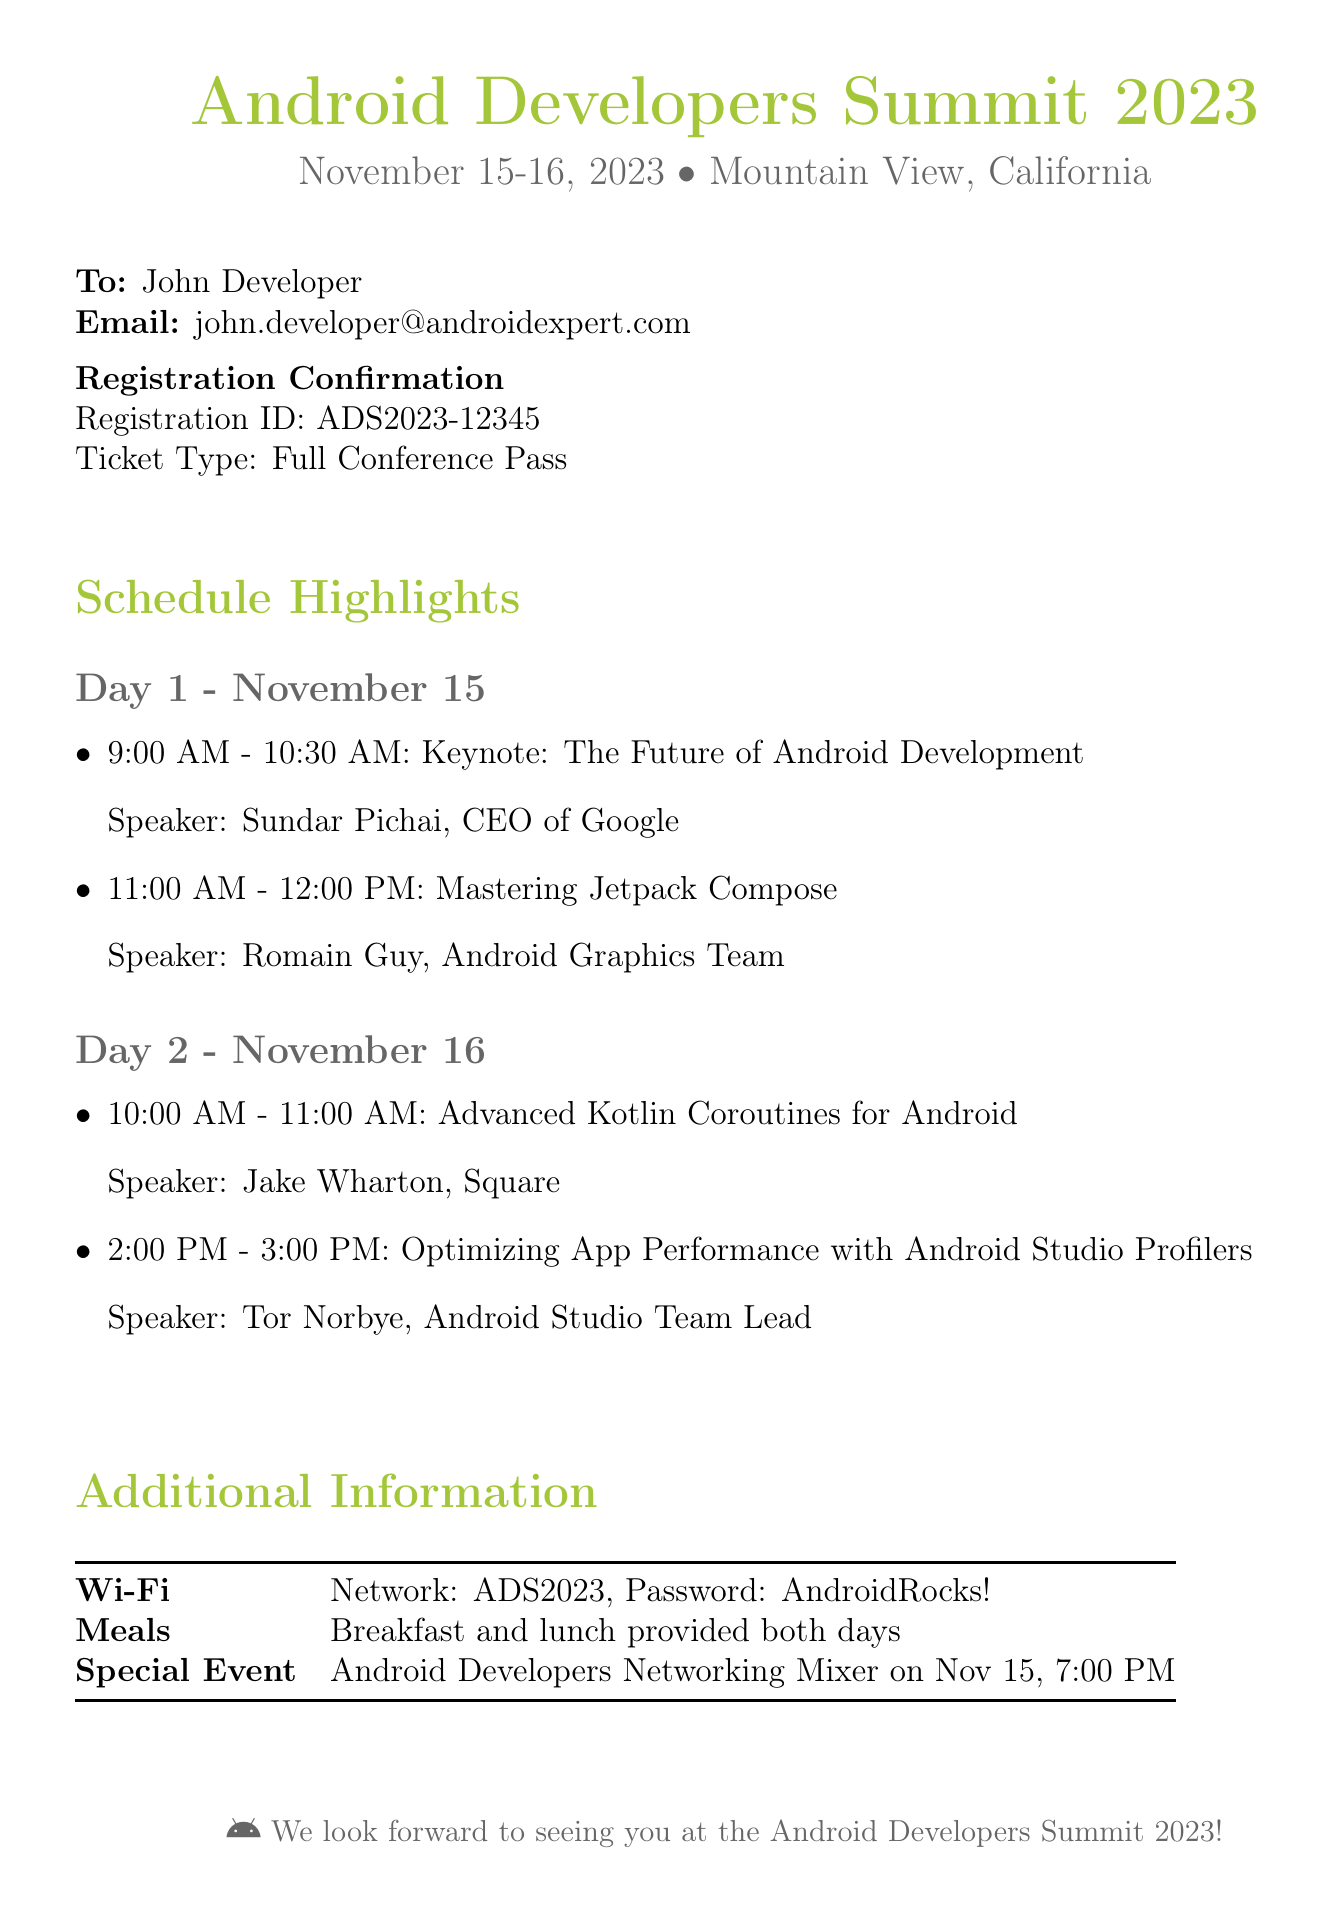What are the conference dates? The conference dates are clearly stated in the document header.
Answer: November 15-16, 2023 Who is the keynote speaker? The keynote speaker is mentioned in the schedule highlights for Day 1.
Answer: Sundar Pichai What is the registration ID? The registration ID is specified under the registration confirmation section.
Answer: ADS2023-12345 When is the Android Developers Networking Mixer scheduled? The timing for the networking mixer is listed in the additional information section.
Answer: Nov 15, 7:00 PM What session is planned for 10:00 AM on Day 2? The schedule for Day 2 includes the session title and time for this slot.
Answer: Advanced Kotlin Coroutines for Android How many meals are provided during the conference? The additional information section mentions meal provisions on both days.
Answer: Breakfast and lunch provided both days What is the Wi-Fi password? The Wi-Fi details are included in the additional information section.
Answer: AndroidRocks! Which company does Jake Wharton work for? The speaker information for the session mentions the speaker's company affiliation.
Answer: Square What is the ticket type for the registration? The ticket type is specified in the registration confirmation section of the fax.
Answer: Full Conference Pass 